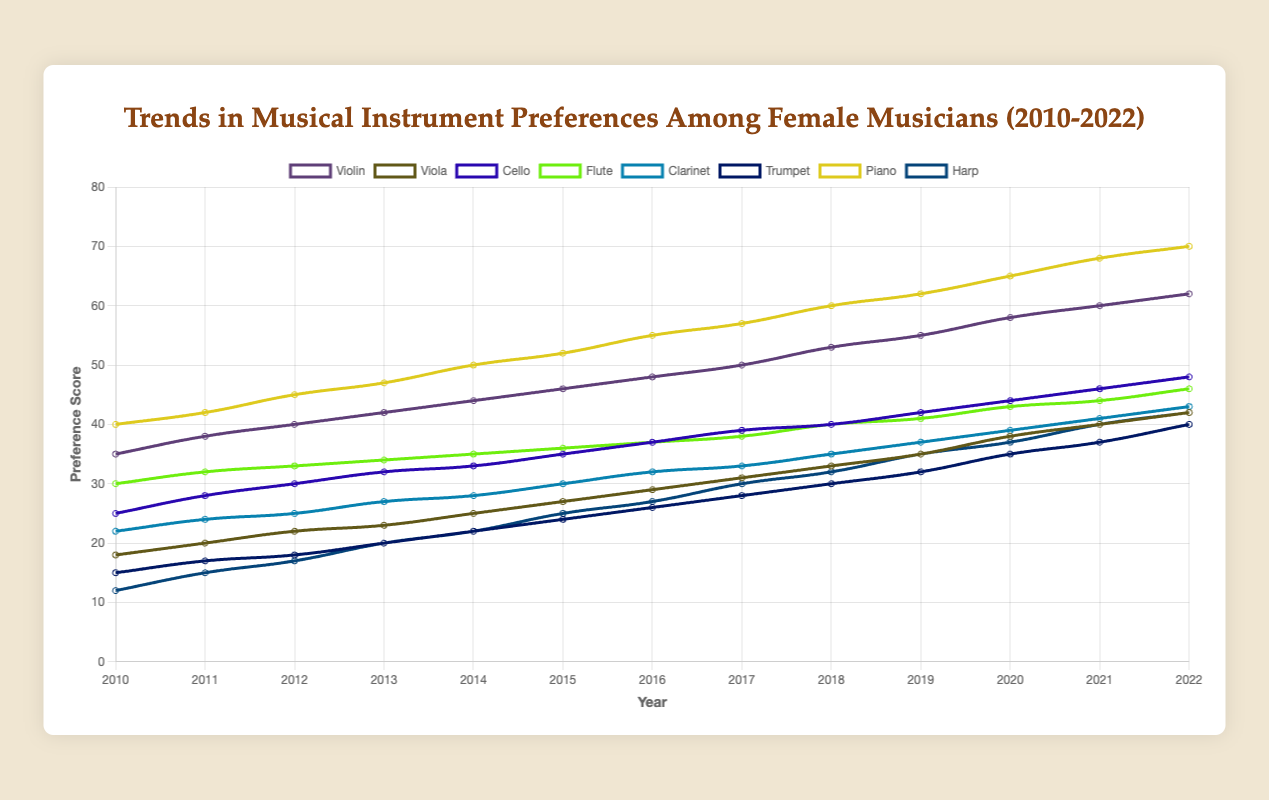What was the preference score for piano in 2020? Look at the data for the year 2020 and check the preference score for piano. It is listed as 65.
Answer: 65 Which instrument had the highest preference in 2016? Check the data for the year 2016 and look for the instrument with the highest score. Piano had the highest score with 55.
Answer: Piano By how much did the preference score for violin increase from 2010 to 2022? Subtract the violin preference score in 2010 from that in 2022: 62 - 35 = 27.
Answer: 27 What is the average preference score for the harp from 2010 to 2022? Sum up the harp scores for each year from 2010 to 2022 and then divide by the number of years: (12 + 15 + 17 + 20 + 22 + 25 + 27 + 30 + 32 + 35 + 37 + 40 + 42) / 13 = 27.
Answer: 27 Did cello ever surpass flute in preference score from 2010 to 2022? Compare the yearly scores of cello and flute for each year. Flute consistently has higher or equal scores than cello every year from 2010 to 2022.
Answer: No Which instrument showed the most steady increase in preference from 2010 to 2022? By observing the data trend for each instrument across the years, it is clear that piano shows a steady increase each year without any dips.
Answer: Piano What is the combined preference score for trumpet and clarinet in 2015? Add the preference scores of trumpet and clarinet in 2015: 24 + 30 = 54.
Answer: 54 Which instruments had an equal preference score in 2018? Check the data for 2018 to find instruments with the same scores. Cello and flute both had a preference score of 40.
Answer: Cello and Flute In which year did viola reach a preference score of 40? Look through the data to find the year when the viola first had a score of 40. It reached 40 in the year 2021.
Answer: 2021 